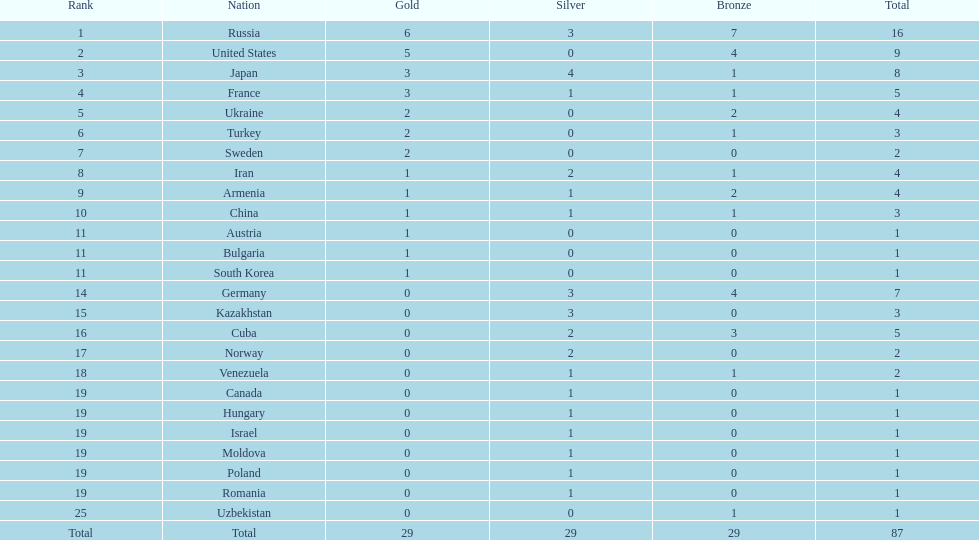How many gold medals have japan and france collectively won? 6. 